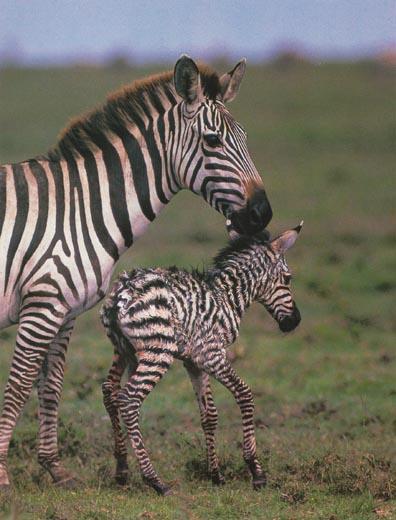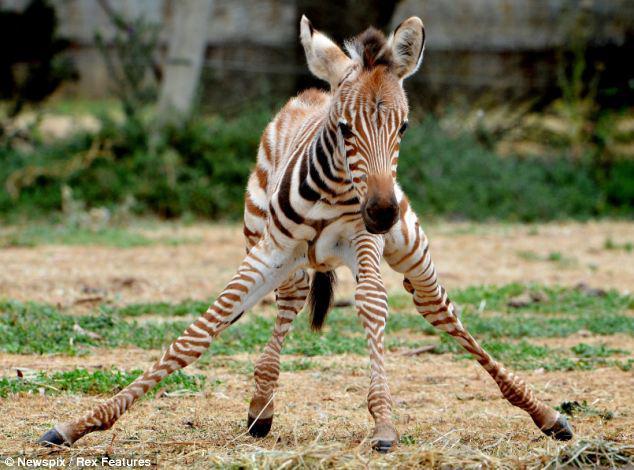The first image is the image on the left, the second image is the image on the right. Assess this claim about the two images: "Each image contains two zebras of similar size, and in at least one image, the head of one zebra is over the back of the other zebra.". Correct or not? Answer yes or no. No. The first image is the image on the left, the second image is the image on the right. Assess this claim about the two images: "At least one baby zebra is staying close to its mom.". Correct or not? Answer yes or no. Yes. 